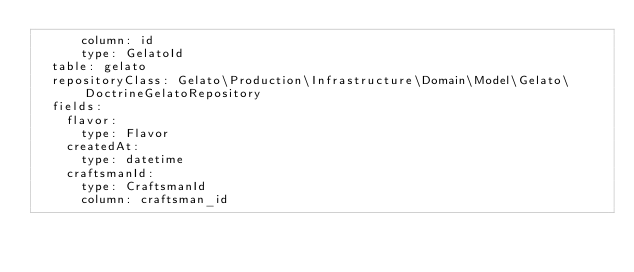<code> <loc_0><loc_0><loc_500><loc_500><_YAML_>      column: id
      type: GelatoId
  table: gelato
  repositoryClass: Gelato\Production\Infrastructure\Domain\Model\Gelato\DoctrineGelatoRepository
  fields:
    flavor:
      type: Flavor
    createdAt:
      type: datetime
    craftsmanId:
      type: CraftsmanId
      column: craftsman_id</code> 